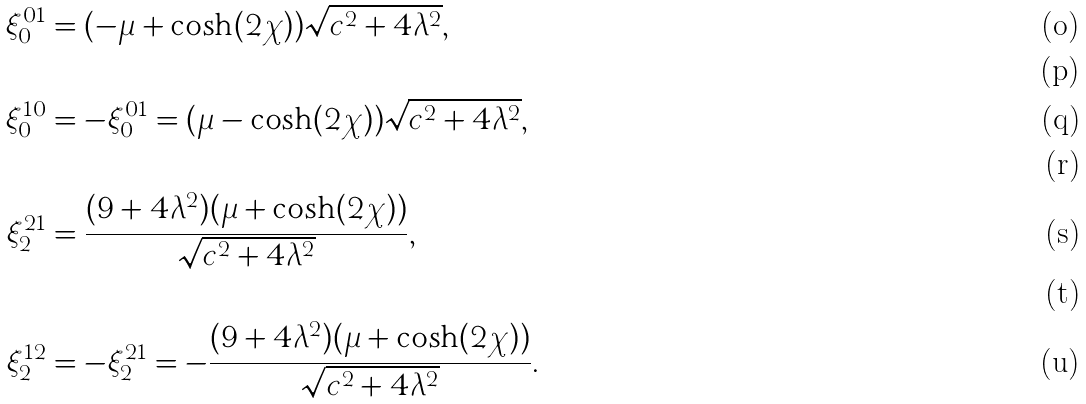Convert formula to latex. <formula><loc_0><loc_0><loc_500><loc_500>\xi _ { 0 } ^ { 0 1 } & = ( - \mu + \cosh ( 2 \chi ) ) \sqrt { c ^ { 2 } + 4 \lambda ^ { 2 } } , \\ \\ \xi _ { 0 } ^ { 1 0 } & = - \xi _ { 0 } ^ { 0 1 } = ( \mu - \cosh ( 2 \chi ) ) \sqrt { c ^ { 2 } + 4 \lambda ^ { 2 } } , \\ \\ \xi _ { 2 } ^ { 2 1 } & = \frac { ( 9 + 4 \lambda ^ { 2 } ) ( \mu + \cosh ( 2 \chi ) ) } { \sqrt { c ^ { 2 } + 4 \lambda ^ { 2 } } } , \\ \\ \xi _ { 2 } ^ { 1 2 } & = - \xi _ { 2 } ^ { 2 1 } = - \frac { ( 9 + 4 \lambda ^ { 2 } ) ( \mu + \cosh ( 2 \chi ) ) } { \sqrt { c ^ { 2 } + 4 \lambda ^ { 2 } } } .</formula> 